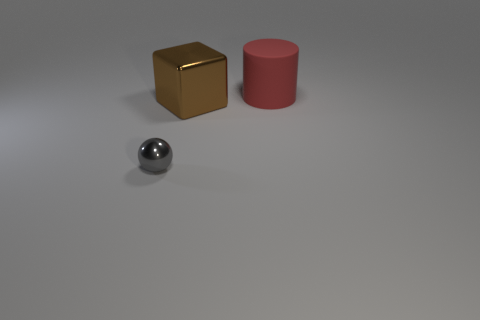Add 1 balls. How many objects exist? 4 Subtract all balls. How many objects are left? 2 Subtract all cyan spheres. Subtract all gray cubes. How many spheres are left? 1 Subtract all big yellow shiny balls. Subtract all large red matte cylinders. How many objects are left? 2 Add 3 large red rubber objects. How many large red rubber objects are left? 4 Add 2 small yellow things. How many small yellow things exist? 2 Subtract 0 purple balls. How many objects are left? 3 